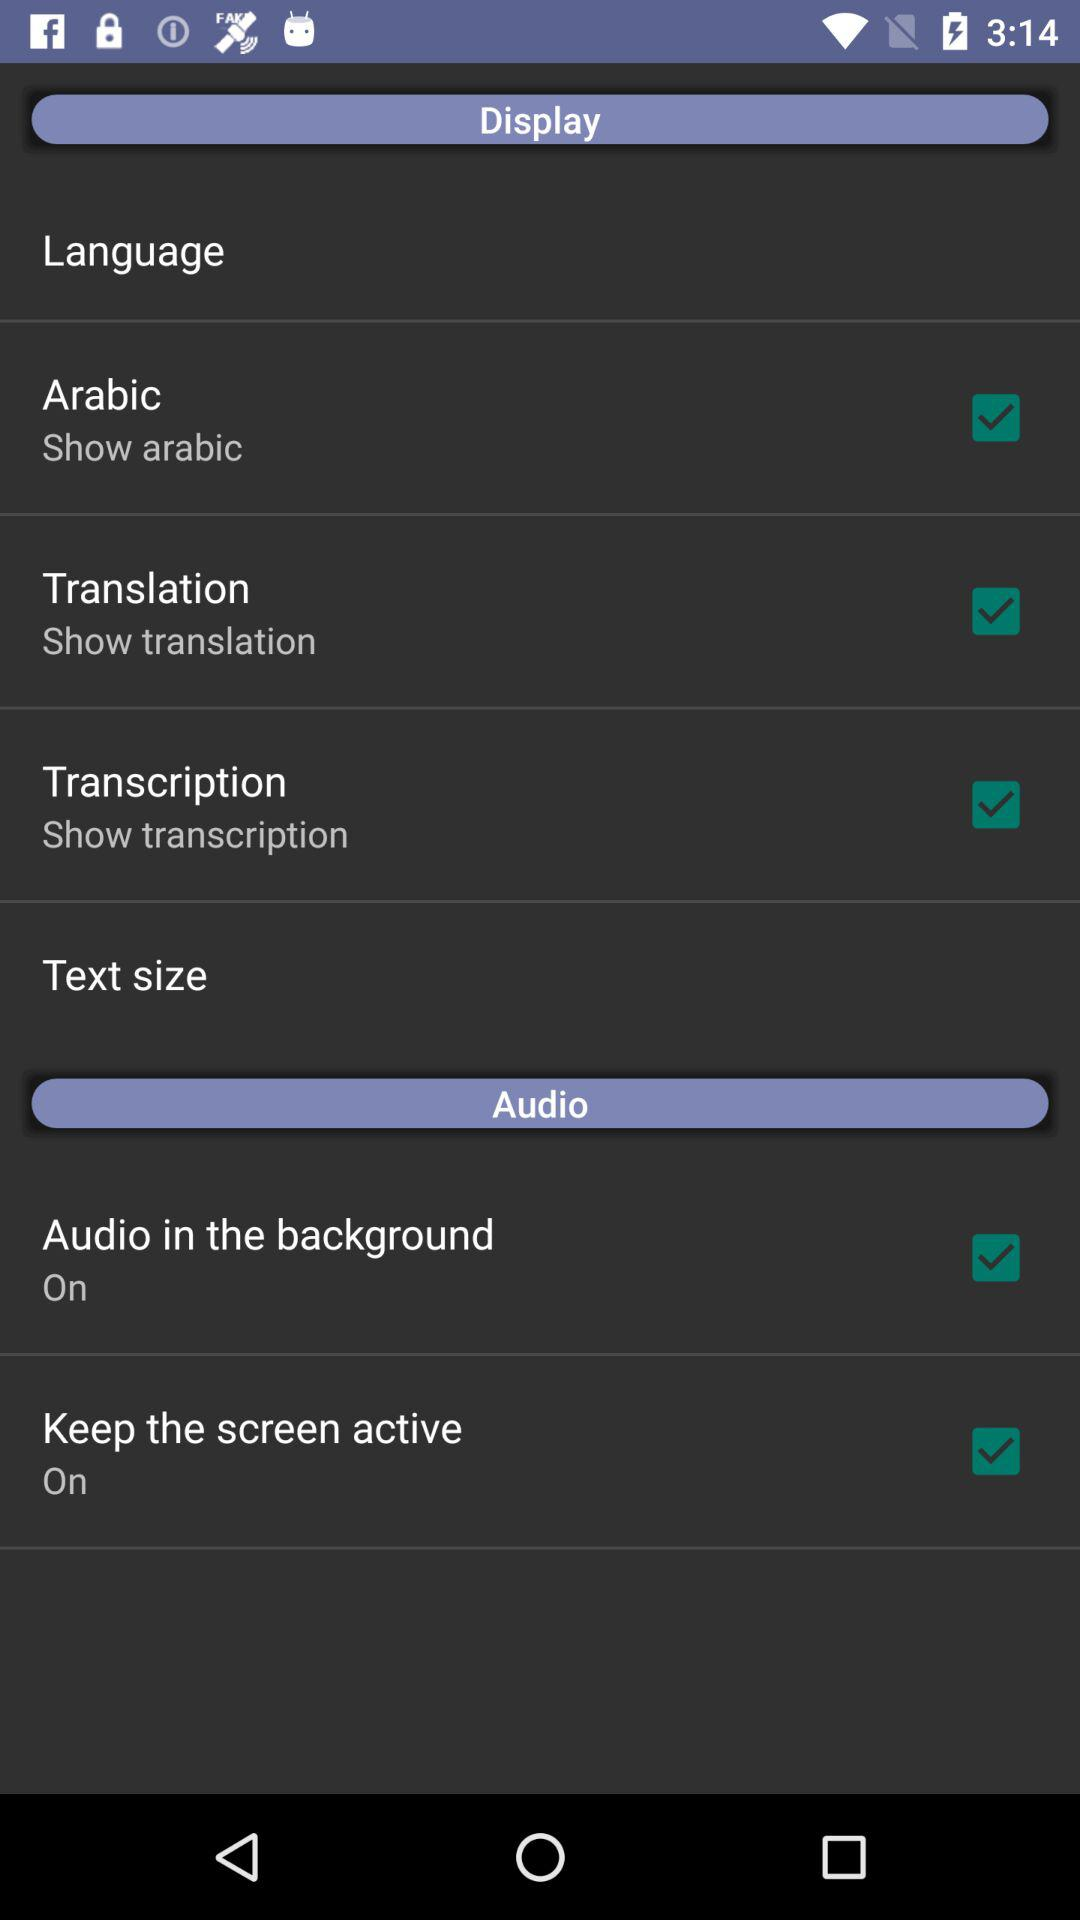How many items have a checkbox in the Audio section?
Answer the question using a single word or phrase. 2 